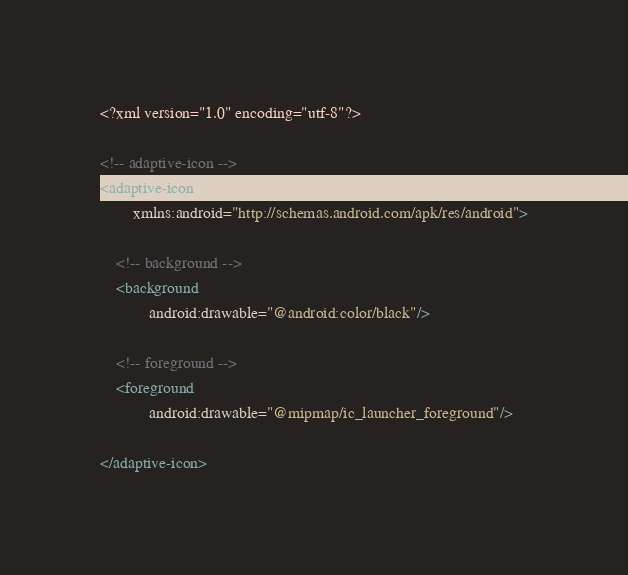<code> <loc_0><loc_0><loc_500><loc_500><_XML_><?xml version="1.0" encoding="utf-8"?>

<!-- adaptive-icon -->
<adaptive-icon
        xmlns:android="http://schemas.android.com/apk/res/android">

    <!-- background -->
    <background
            android:drawable="@android:color/black"/>

    <!-- foreground -->
    <foreground
            android:drawable="@mipmap/ic_launcher_foreground"/>

</adaptive-icon>
</code> 